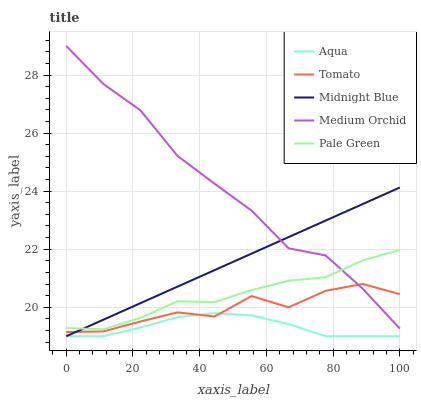Does Aqua have the minimum area under the curve?
Answer yes or no. Yes. Does Medium Orchid have the maximum area under the curve?
Answer yes or no. Yes. Does Pale Green have the minimum area under the curve?
Answer yes or no. No. Does Pale Green have the maximum area under the curve?
Answer yes or no. No. Is Midnight Blue the smoothest?
Answer yes or no. Yes. Is Tomato the roughest?
Answer yes or no. Yes. Is Pale Green the smoothest?
Answer yes or no. No. Is Pale Green the roughest?
Answer yes or no. No. Does Aqua have the lowest value?
Answer yes or no. Yes. Does Pale Green have the lowest value?
Answer yes or no. No. Does Medium Orchid have the highest value?
Answer yes or no. Yes. Does Pale Green have the highest value?
Answer yes or no. No. Is Tomato less than Pale Green?
Answer yes or no. Yes. Is Medium Orchid greater than Aqua?
Answer yes or no. Yes. Does Pale Green intersect Medium Orchid?
Answer yes or no. Yes. Is Pale Green less than Medium Orchid?
Answer yes or no. No. Is Pale Green greater than Medium Orchid?
Answer yes or no. No. Does Tomato intersect Pale Green?
Answer yes or no. No. 